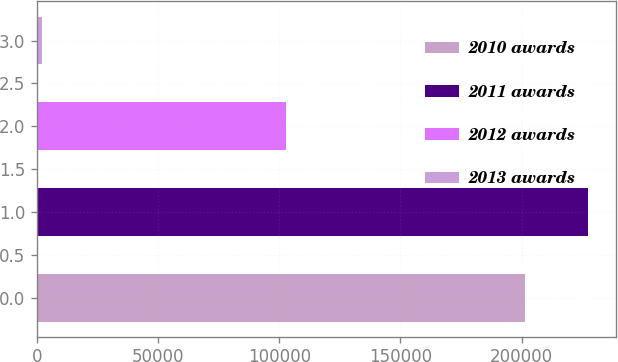Convert chart to OTSL. <chart><loc_0><loc_0><loc_500><loc_500><bar_chart><fcel>2010 awards<fcel>2011 awards<fcel>2012 awards<fcel>2013 awards<nl><fcel>201422<fcel>227571<fcel>102855<fcel>2180<nl></chart> 